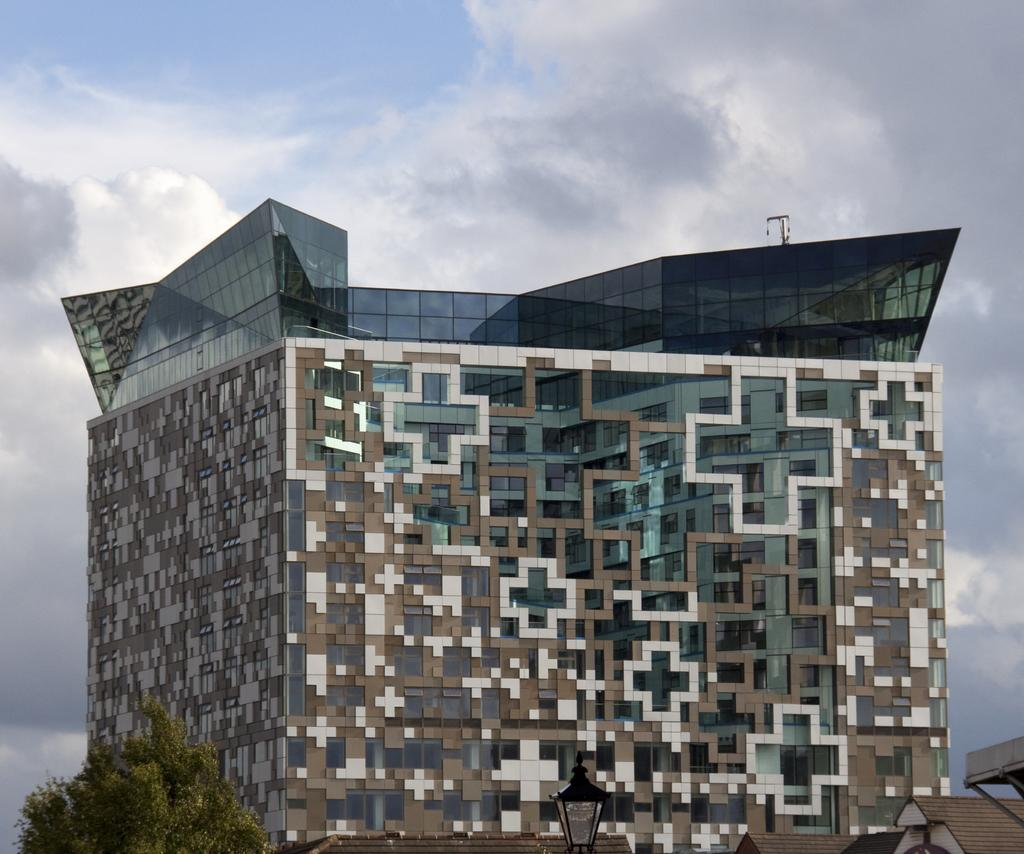What type of structures can be seen in the image? There are buildings in the image. What else is visible in the image besides the buildings? There are lights and a tree visible in the image. What is visible in the sky at the top of the image? Clouds are visible in the sky at the top of the image. What type of sand can be seen on the ground in the image? There is no sand visible on the ground in the image; it features buildings, lights, a tree, and clouds in the sky. 